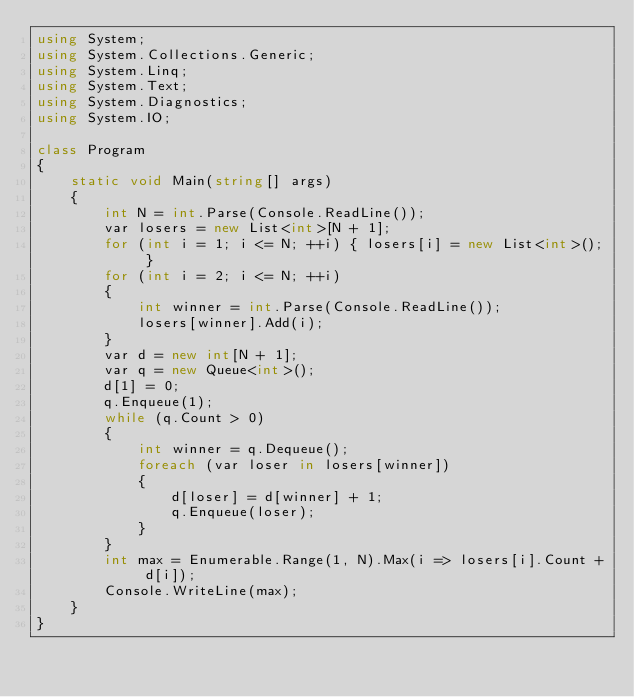Convert code to text. <code><loc_0><loc_0><loc_500><loc_500><_C#_>using System;
using System.Collections.Generic;
using System.Linq;
using System.Text;
using System.Diagnostics;
using System.IO;

class Program
{
    static void Main(string[] args)
    {
        int N = int.Parse(Console.ReadLine());
        var losers = new List<int>[N + 1];
        for (int i = 1; i <= N; ++i) { losers[i] = new List<int>(); }
        for (int i = 2; i <= N; ++i)
        {
            int winner = int.Parse(Console.ReadLine());
            losers[winner].Add(i);
        }
        var d = new int[N + 1];
        var q = new Queue<int>();
        d[1] = 0;
        q.Enqueue(1);
        while (q.Count > 0)
        {
            int winner = q.Dequeue();
            foreach (var loser in losers[winner])
            {
                d[loser] = d[winner] + 1;
                q.Enqueue(loser);
            }
        }
        int max = Enumerable.Range(1, N).Max(i => losers[i].Count + d[i]);
        Console.WriteLine(max);
    }
}
</code> 